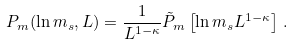Convert formula to latex. <formula><loc_0><loc_0><loc_500><loc_500>P _ { m } ( \ln m _ { s } , L ) = \frac { 1 } { L ^ { 1 - \kappa } } \tilde { P } _ { m } \left [ { \ln m _ { s } } { L ^ { 1 - \kappa } } \right ] \, .</formula> 